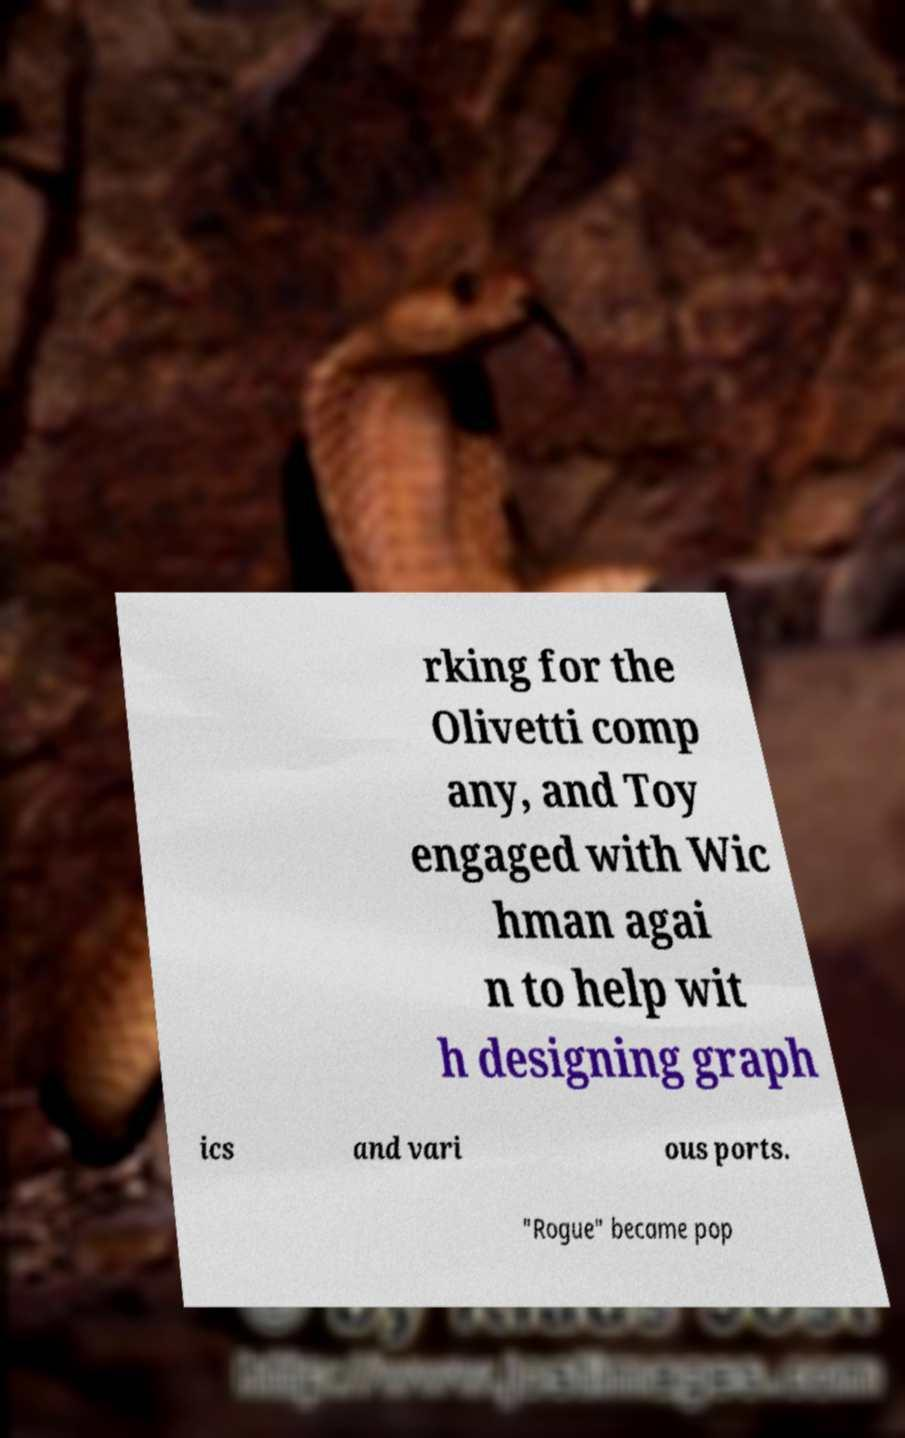What messages or text are displayed in this image? I need them in a readable, typed format. rking for the Olivetti comp any, and Toy engaged with Wic hman agai n to help wit h designing graph ics and vari ous ports. "Rogue" became pop 